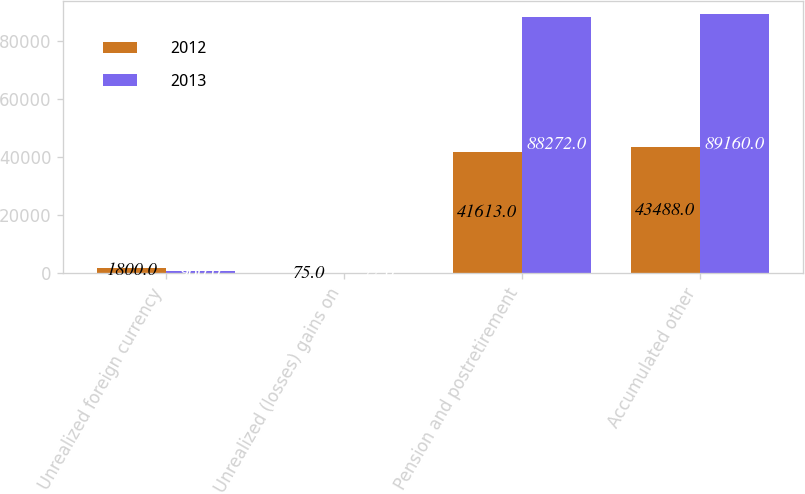Convert chart. <chart><loc_0><loc_0><loc_500><loc_500><stacked_bar_chart><ecel><fcel>Unrealized foreign currency<fcel>Unrealized (losses) gains on<fcel>Pension and postretirement<fcel>Accumulated other<nl><fcel>2012<fcel>1800<fcel>75<fcel>41613<fcel>43488<nl><fcel>2013<fcel>960<fcel>72<fcel>88272<fcel>89160<nl></chart> 